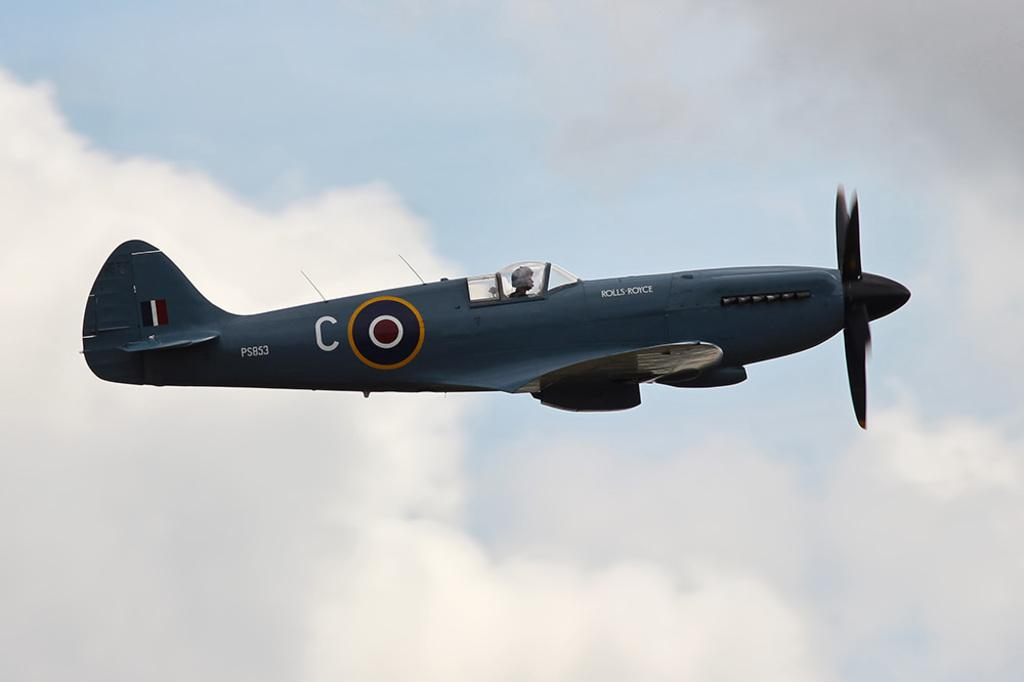<image>
Provide a brief description of the given image. A single person Rolls Royce plane flying in the sky. 